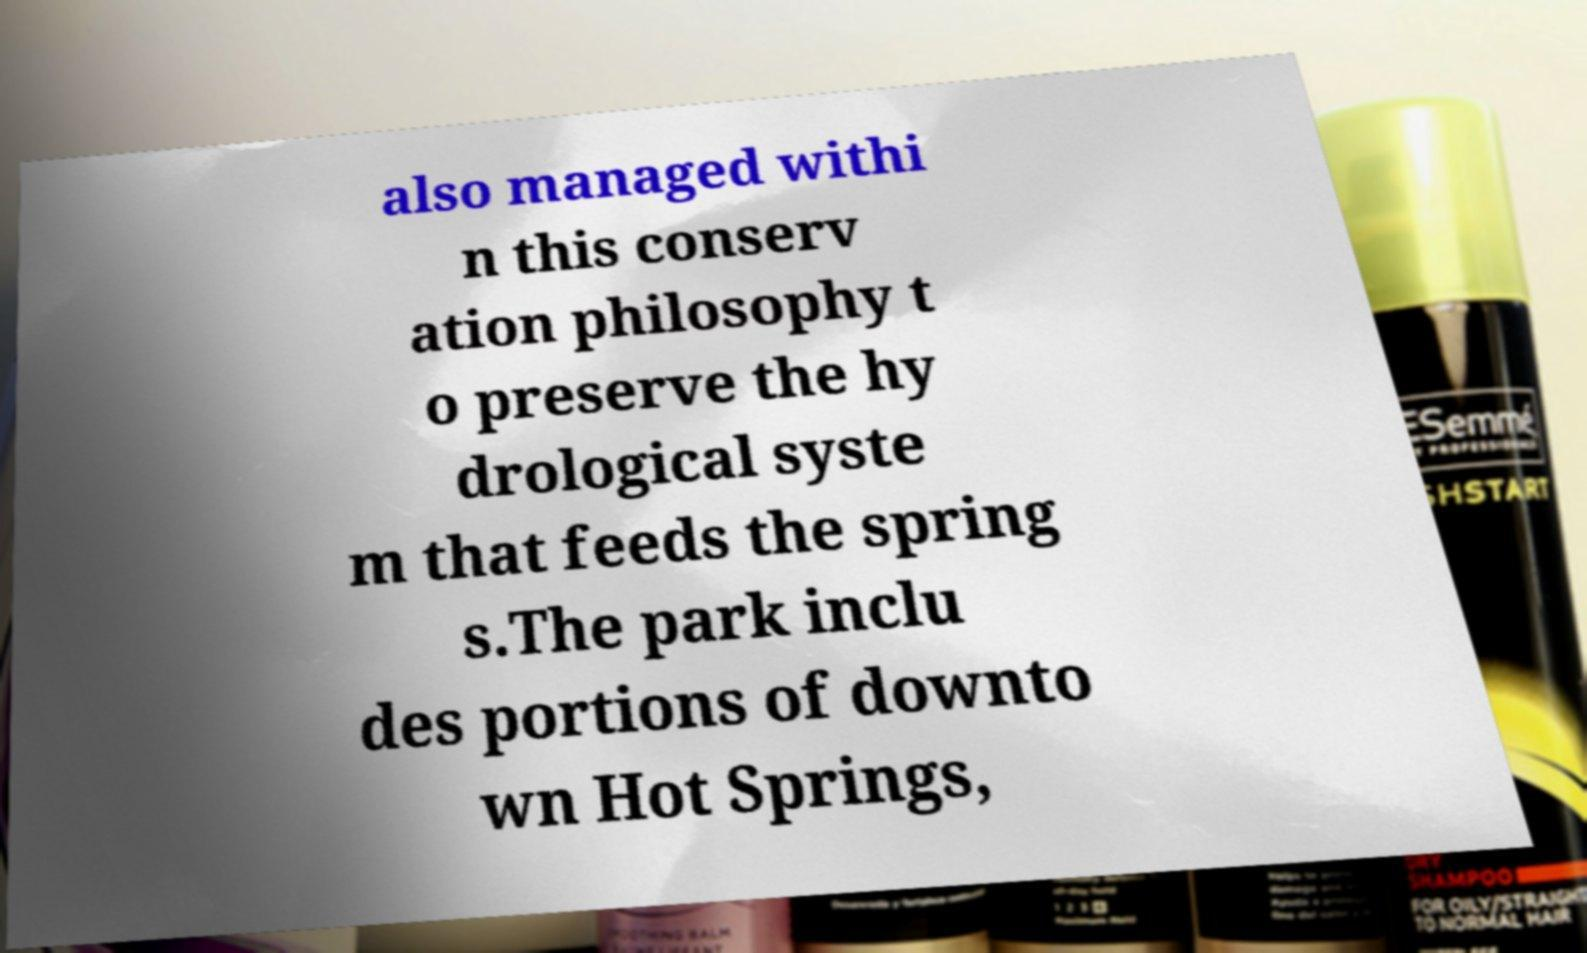Could you extract and type out the text from this image? also managed withi n this conserv ation philosophy t o preserve the hy drological syste m that feeds the spring s.The park inclu des portions of downto wn Hot Springs, 